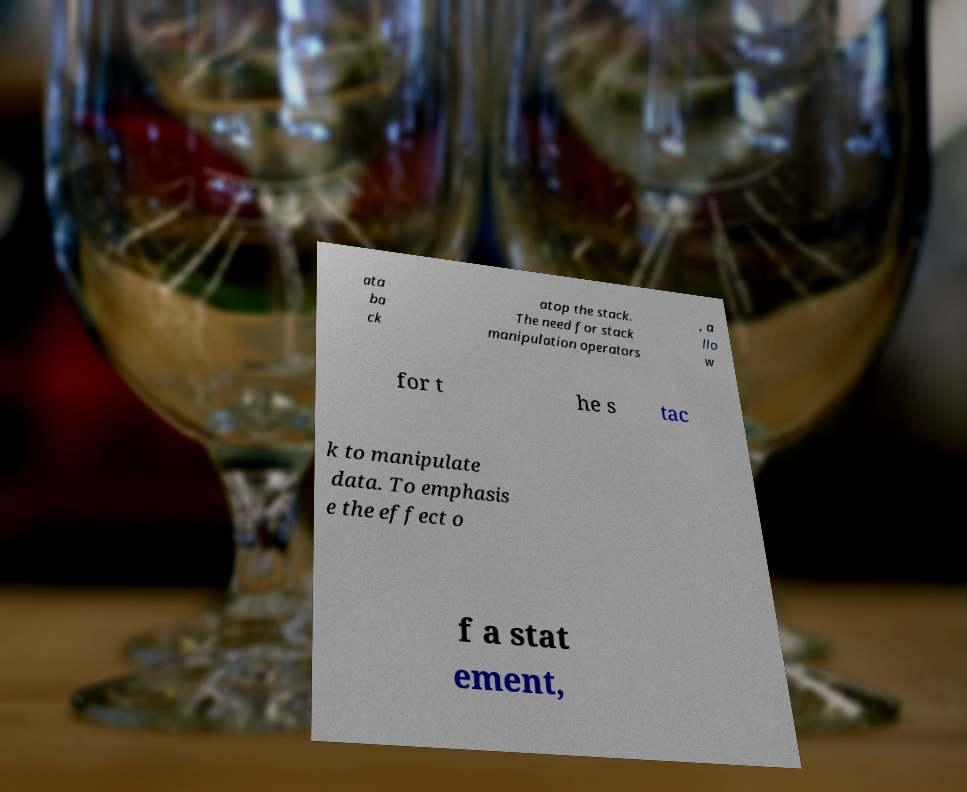For documentation purposes, I need the text within this image transcribed. Could you provide that? ata ba ck atop the stack. The need for stack manipulation operators , a llo w for t he s tac k to manipulate data. To emphasis e the effect o f a stat ement, 